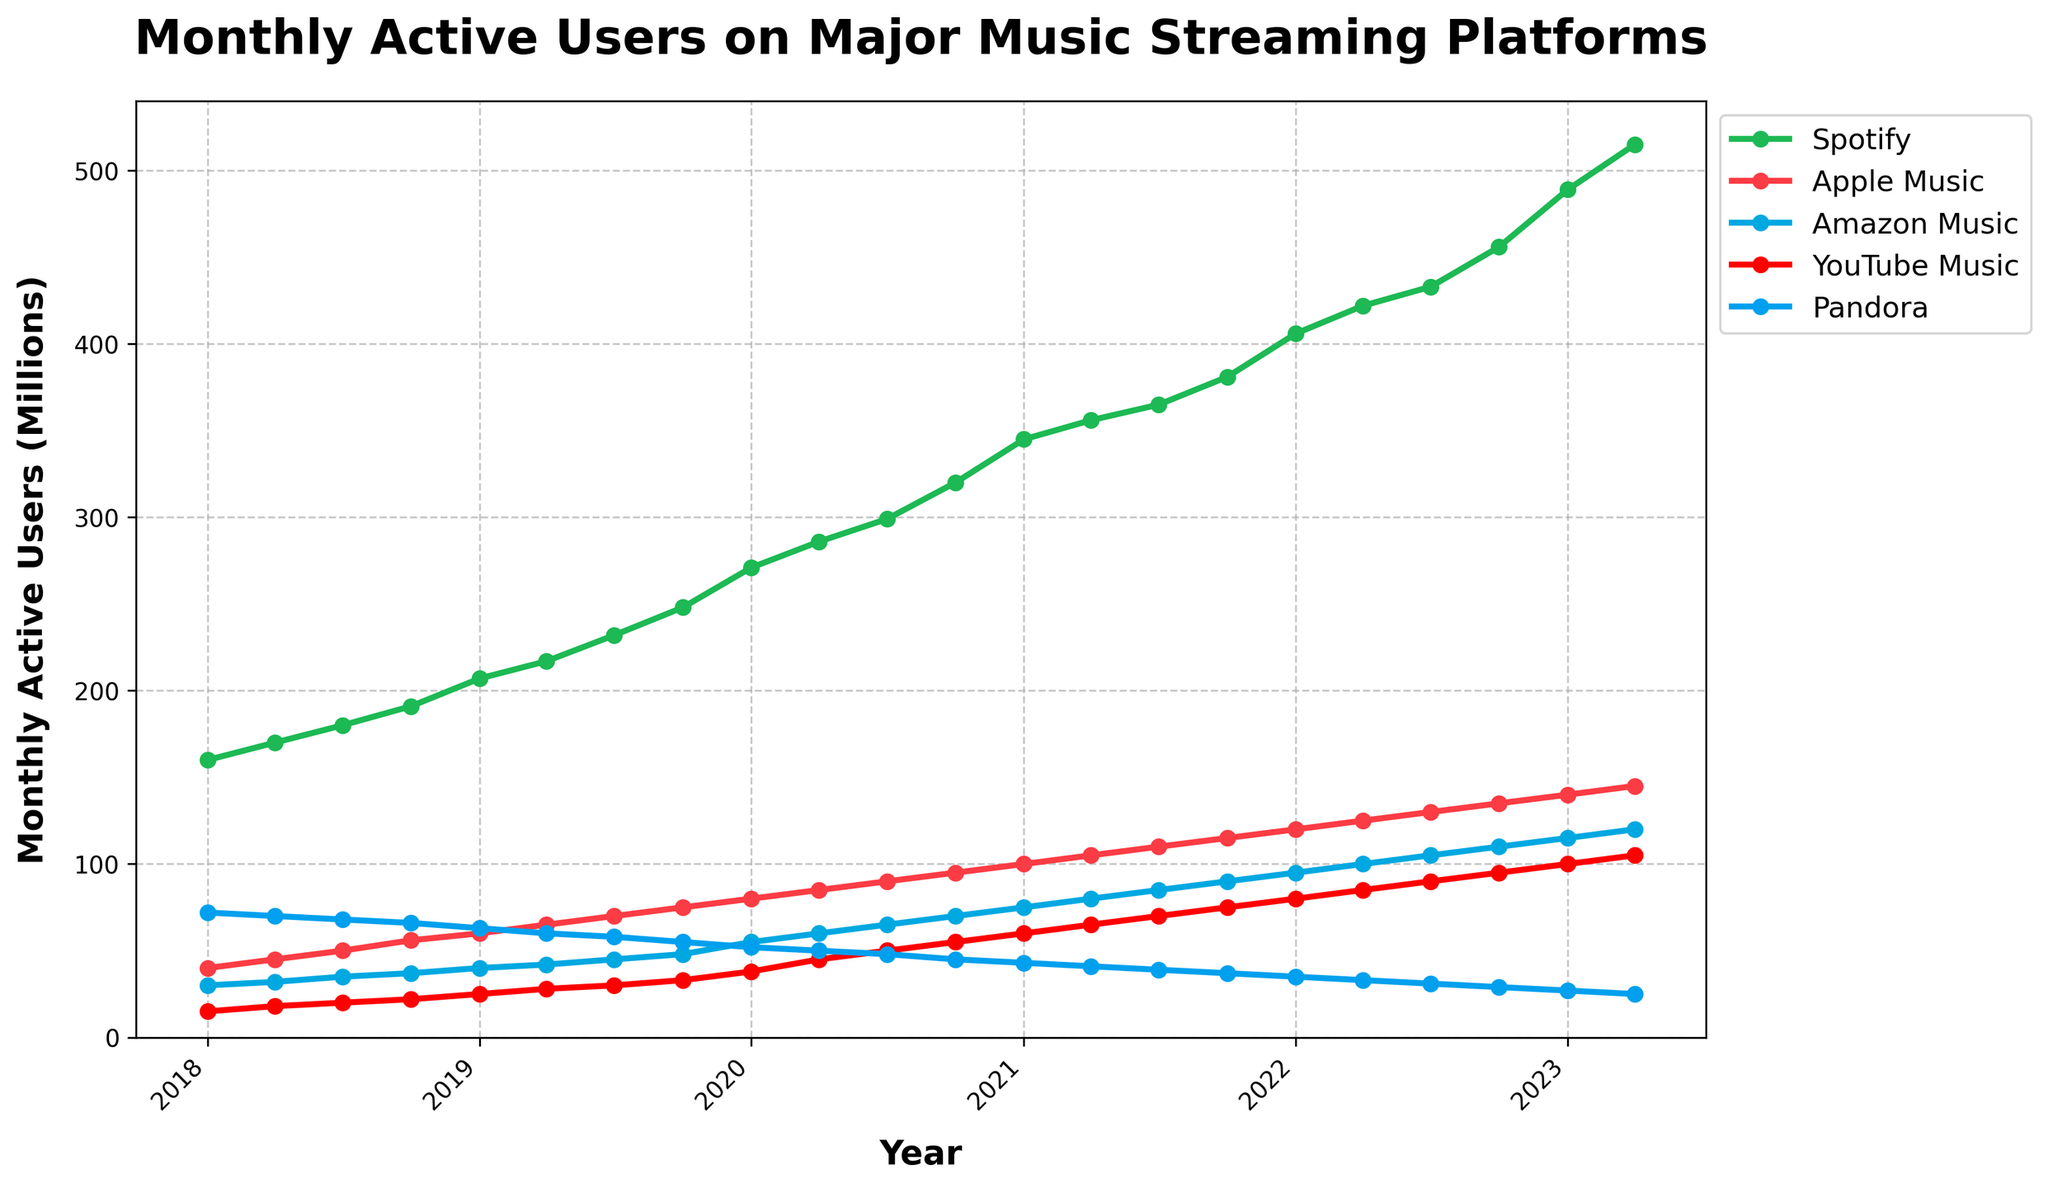What is the overall trend for Spotify users over the past 5 years? The plot shows that the number of monthly active Spotify users has been steadily increasing over the past 5 years, starting from 160 million in Jan 2018 to 515 million in Apr 2023.
Answer: Increasing Which platform had the smallest increase in users from Jan 2018 to Apr 2023? To find the answer, subtract the number of users in Jan 2018 from the number of users in Apr 2023 for each platform. The values are: Spotify (515 - 160 = 355), Apple Music (145 - 40 = 105), Amazon Music (120 - 30 = 90), YouTube Music (105 - 15 = 90), Pandora (25 - 72 = -47). Pandora had the smallest increase (actually a decrease).
Answer: Pandora In which year did Apple Music have 100 million monthly active users? Look at where the Apple Music line crosses the 100 million user mark on the y-axis, which corresponds to Jan 2021.
Answer: 2021 How many more users did Spotify have than Pandora in Apr 2023? Subtract the number of Pandora users from the number of Spotify users in Apr 2023. That is 515 million (Spotify) - 25 million (Pandora) = 490 million.
Answer: 490 million For the month of Oct 2020, which platform had the second highest number of users? Check the values for Oct 2020 on the line chart: Spotify (320 million), Apple Music (95 million), Amazon Music (70 million), YouTube Music (55 million), Pandora (45 million). Apple Music had the second highest number of users.
Answer: Apple Music What is the average number of monthly active users for YouTube Music in 2019? The YouTube Music values for 2019 are: 25 (Jan), 28 (Apr), 30 (Jul), 33 (Oct). Calculate the average: (25 + 28 + 30 + 33)/4 = 116/4 = 29.
Answer: 29 million Which platform exhibited the fastest growth between Jan 2020 and Jan 2023? Calculate the difference between the values for Jan 2020 and Jan 2023 for each platform: Spotify (489 - 271 = 218), Apple Music (140 - 80 = 60), Amazon Music (115 - 55 = 60), YouTube Music (100 - 38 = 62), Pandora (27 - 52 = -25). Spotify exhibited the fastest growth with an increase of 218 million users.
Answer: Spotify Between which consecutive months did Amazon Music see the highest growth in users, and what was this growth? Compare the differences in Amazon Music users between consecutive months and find the maximum difference. The highest growth was between Jan 2020 (55 million) and Apr 2020 (60 million), with an increase of 5 million users.
Answer: Jan 2020 to Apr 2020, 5 million What is the total number of monthly active users for all platforms combined in Jul 2021? Sum the number of users for each platform in Jul 2021: Spotify (365) + Apple Music (110) + Amazon Music (85) + YouTube Music (70) + Pandora (39) = 669 million.
Answer: 669 million 